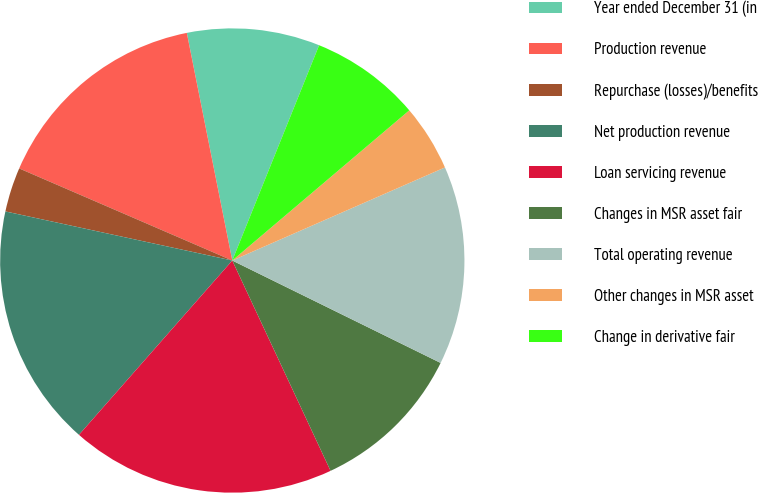Convert chart to OTSL. <chart><loc_0><loc_0><loc_500><loc_500><pie_chart><fcel>Year ended December 31 (in<fcel>Production revenue<fcel>Repurchase (losses)/benefits<fcel>Net production revenue<fcel>Loan servicing revenue<fcel>Changes in MSR asset fair<fcel>Total operating revenue<fcel>Other changes in MSR asset<fcel>Change in derivative fair<nl><fcel>9.24%<fcel>15.37%<fcel>3.1%<fcel>16.91%<fcel>18.44%<fcel>10.77%<fcel>13.84%<fcel>4.63%<fcel>7.7%<nl></chart> 